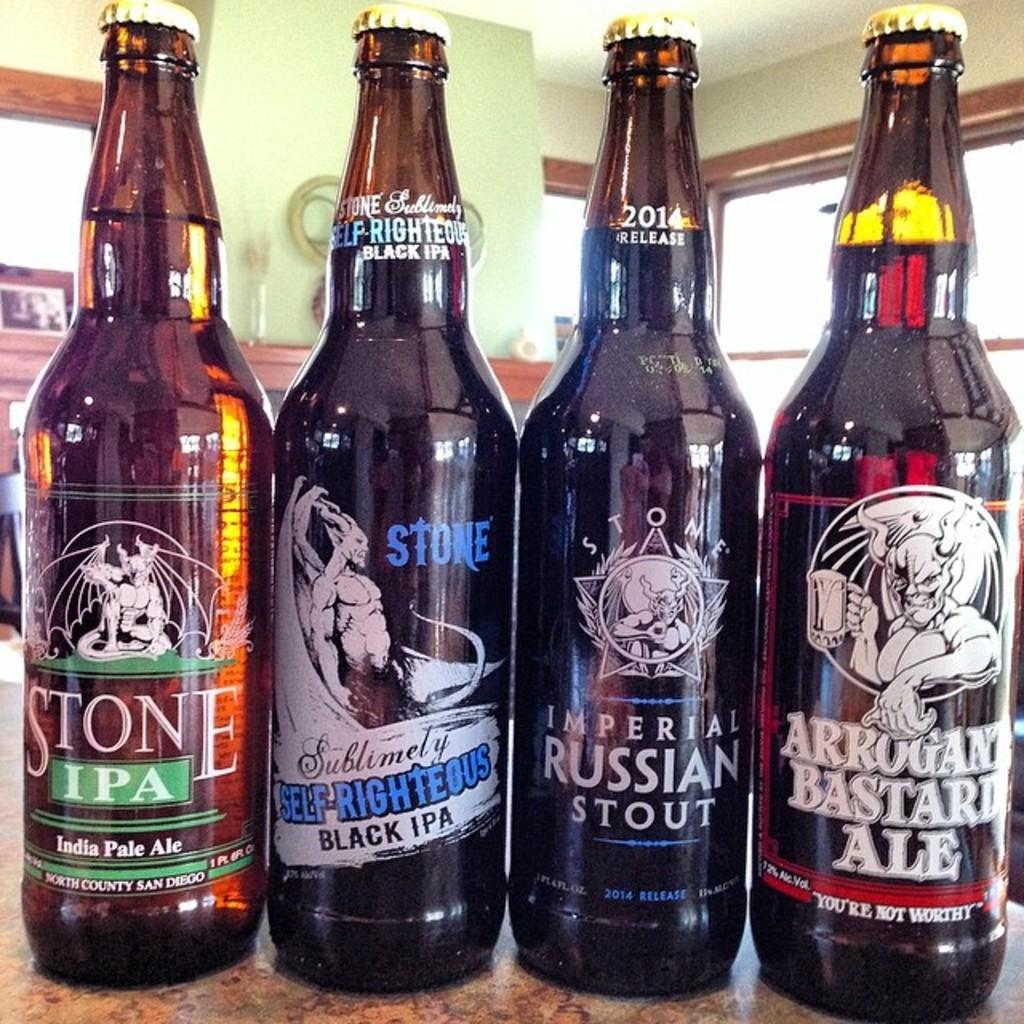<image>
Render a clear and concise summary of the photo. A bottle of Imperial Russian Stout is in between other bottles. 